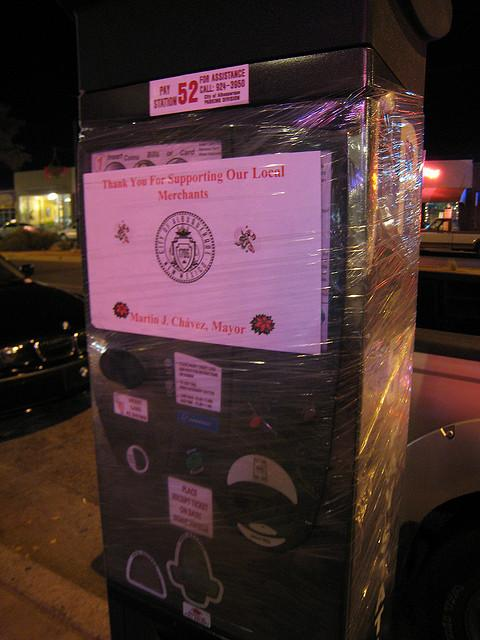This machine is meant to assist what type people in payments? Please explain your reasoning. motorists. The machine is used for motor bikes. 